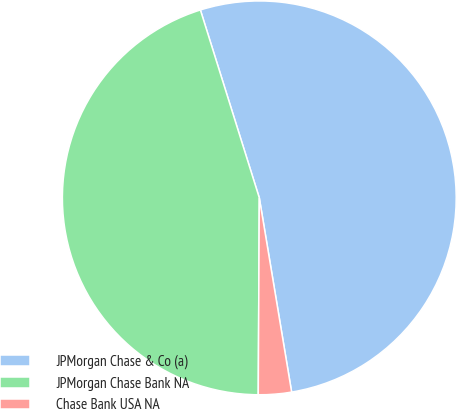Convert chart. <chart><loc_0><loc_0><loc_500><loc_500><pie_chart><fcel>JPMorgan Chase & Co (a)<fcel>JPMorgan Chase Bank NA<fcel>Chase Bank USA NA<nl><fcel>52.21%<fcel>45.08%<fcel>2.71%<nl></chart> 